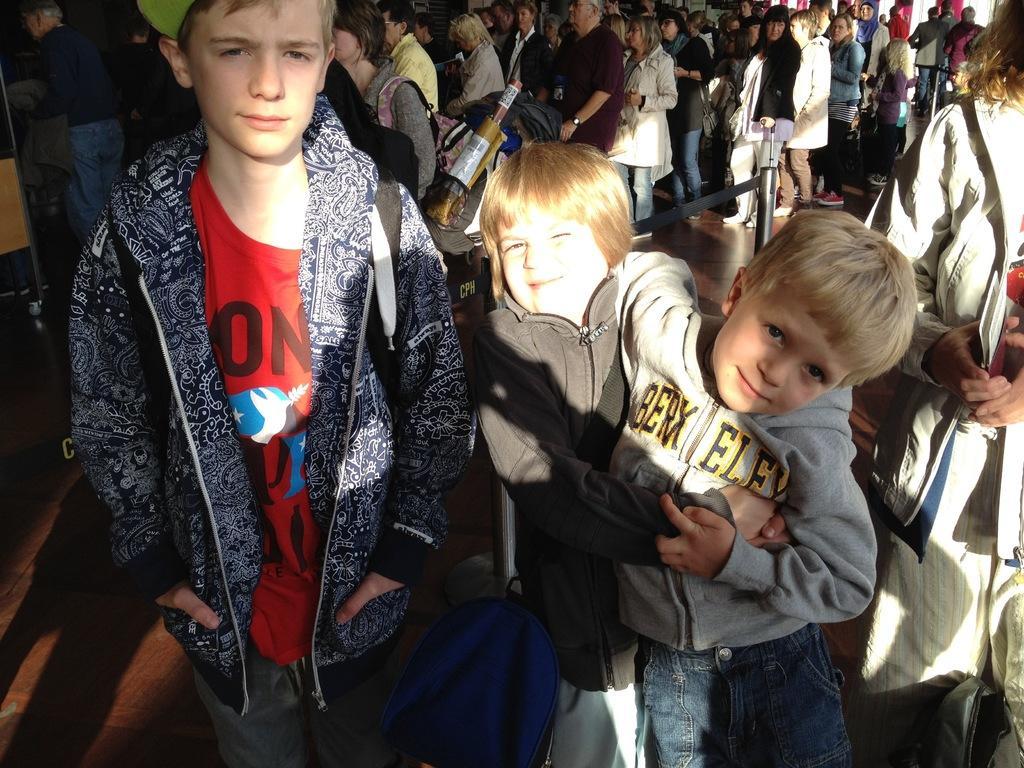Can you describe this image briefly? In this image we can see the crowd. 